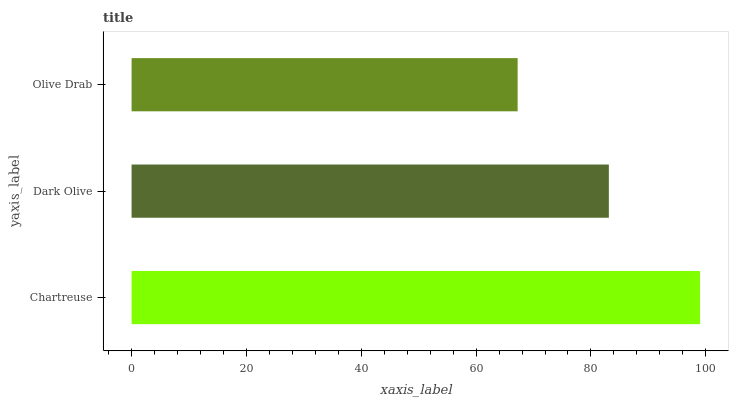Is Olive Drab the minimum?
Answer yes or no. Yes. Is Chartreuse the maximum?
Answer yes or no. Yes. Is Dark Olive the minimum?
Answer yes or no. No. Is Dark Olive the maximum?
Answer yes or no. No. Is Chartreuse greater than Dark Olive?
Answer yes or no. Yes. Is Dark Olive less than Chartreuse?
Answer yes or no. Yes. Is Dark Olive greater than Chartreuse?
Answer yes or no. No. Is Chartreuse less than Dark Olive?
Answer yes or no. No. Is Dark Olive the high median?
Answer yes or no. Yes. Is Dark Olive the low median?
Answer yes or no. Yes. Is Olive Drab the high median?
Answer yes or no. No. Is Chartreuse the low median?
Answer yes or no. No. 